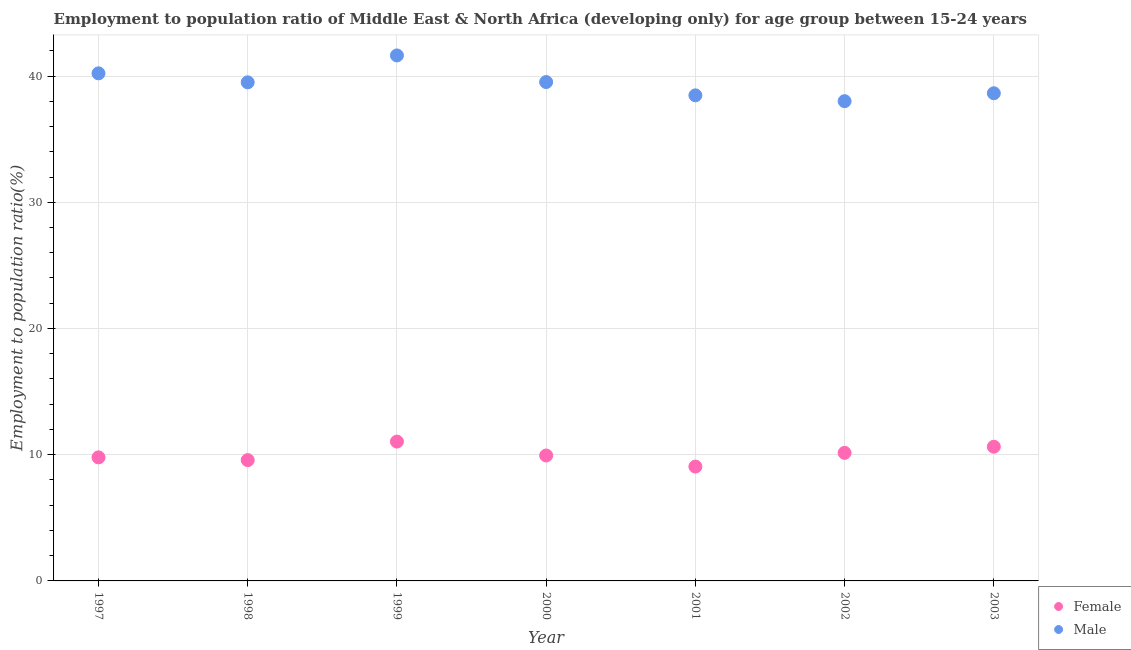Is the number of dotlines equal to the number of legend labels?
Your response must be concise. Yes. What is the employment to population ratio(female) in 2000?
Your answer should be very brief. 9.94. Across all years, what is the maximum employment to population ratio(male)?
Your answer should be very brief. 41.63. Across all years, what is the minimum employment to population ratio(female)?
Your response must be concise. 9.06. What is the total employment to population ratio(female) in the graph?
Offer a very short reply. 70.17. What is the difference between the employment to population ratio(female) in 2001 and that in 2002?
Your answer should be compact. -1.09. What is the difference between the employment to population ratio(male) in 1997 and the employment to population ratio(female) in 1998?
Your answer should be compact. 30.64. What is the average employment to population ratio(female) per year?
Your response must be concise. 10.02. In the year 1999, what is the difference between the employment to population ratio(female) and employment to population ratio(male)?
Offer a terse response. -30.59. In how many years, is the employment to population ratio(female) greater than 6 %?
Make the answer very short. 7. What is the ratio of the employment to population ratio(female) in 1997 to that in 1998?
Provide a succinct answer. 1.02. What is the difference between the highest and the second highest employment to population ratio(female)?
Ensure brevity in your answer.  0.41. What is the difference between the highest and the lowest employment to population ratio(female)?
Make the answer very short. 1.98. Is the employment to population ratio(female) strictly less than the employment to population ratio(male) over the years?
Your answer should be compact. Yes. Are the values on the major ticks of Y-axis written in scientific E-notation?
Give a very brief answer. No. Does the graph contain any zero values?
Ensure brevity in your answer.  No. Does the graph contain grids?
Make the answer very short. Yes. How are the legend labels stacked?
Keep it short and to the point. Vertical. What is the title of the graph?
Offer a very short reply. Employment to population ratio of Middle East & North Africa (developing only) for age group between 15-24 years. What is the label or title of the X-axis?
Provide a succinct answer. Year. What is the label or title of the Y-axis?
Your answer should be compact. Employment to population ratio(%). What is the Employment to population ratio(%) in Female in 1997?
Make the answer very short. 9.79. What is the Employment to population ratio(%) of Male in 1997?
Offer a very short reply. 40.21. What is the Employment to population ratio(%) of Female in 1998?
Your answer should be compact. 9.57. What is the Employment to population ratio(%) of Male in 1998?
Your response must be concise. 39.5. What is the Employment to population ratio(%) in Female in 1999?
Ensure brevity in your answer.  11.04. What is the Employment to population ratio(%) in Male in 1999?
Provide a succinct answer. 41.63. What is the Employment to population ratio(%) in Female in 2000?
Offer a very short reply. 9.94. What is the Employment to population ratio(%) of Male in 2000?
Provide a short and direct response. 39.52. What is the Employment to population ratio(%) in Female in 2001?
Your answer should be compact. 9.06. What is the Employment to population ratio(%) of Male in 2001?
Provide a succinct answer. 38.47. What is the Employment to population ratio(%) in Female in 2002?
Offer a terse response. 10.15. What is the Employment to population ratio(%) of Male in 2002?
Your answer should be very brief. 38.01. What is the Employment to population ratio(%) in Female in 2003?
Your answer should be compact. 10.63. What is the Employment to population ratio(%) of Male in 2003?
Keep it short and to the point. 38.63. Across all years, what is the maximum Employment to population ratio(%) in Female?
Keep it short and to the point. 11.04. Across all years, what is the maximum Employment to population ratio(%) of Male?
Provide a succinct answer. 41.63. Across all years, what is the minimum Employment to population ratio(%) in Female?
Give a very brief answer. 9.06. Across all years, what is the minimum Employment to population ratio(%) in Male?
Provide a succinct answer. 38.01. What is the total Employment to population ratio(%) in Female in the graph?
Provide a short and direct response. 70.17. What is the total Employment to population ratio(%) of Male in the graph?
Your answer should be very brief. 275.98. What is the difference between the Employment to population ratio(%) of Female in 1997 and that in 1998?
Give a very brief answer. 0.22. What is the difference between the Employment to population ratio(%) of Male in 1997 and that in 1998?
Make the answer very short. 0.71. What is the difference between the Employment to population ratio(%) of Female in 1997 and that in 1999?
Provide a short and direct response. -1.25. What is the difference between the Employment to population ratio(%) in Male in 1997 and that in 1999?
Make the answer very short. -1.42. What is the difference between the Employment to population ratio(%) in Female in 1997 and that in 2000?
Offer a terse response. -0.15. What is the difference between the Employment to population ratio(%) of Male in 1997 and that in 2000?
Offer a terse response. 0.69. What is the difference between the Employment to population ratio(%) in Female in 1997 and that in 2001?
Ensure brevity in your answer.  0.73. What is the difference between the Employment to population ratio(%) of Male in 1997 and that in 2001?
Your response must be concise. 1.74. What is the difference between the Employment to population ratio(%) in Female in 1997 and that in 2002?
Provide a succinct answer. -0.36. What is the difference between the Employment to population ratio(%) in Male in 1997 and that in 2002?
Ensure brevity in your answer.  2.21. What is the difference between the Employment to population ratio(%) of Female in 1997 and that in 2003?
Your response must be concise. -0.84. What is the difference between the Employment to population ratio(%) in Male in 1997 and that in 2003?
Your answer should be very brief. 1.58. What is the difference between the Employment to population ratio(%) of Female in 1998 and that in 1999?
Offer a terse response. -1.47. What is the difference between the Employment to population ratio(%) in Male in 1998 and that in 1999?
Give a very brief answer. -2.13. What is the difference between the Employment to population ratio(%) of Female in 1998 and that in 2000?
Offer a very short reply. -0.37. What is the difference between the Employment to population ratio(%) in Male in 1998 and that in 2000?
Offer a terse response. -0.02. What is the difference between the Employment to population ratio(%) of Female in 1998 and that in 2001?
Your answer should be very brief. 0.51. What is the difference between the Employment to population ratio(%) in Male in 1998 and that in 2001?
Your response must be concise. 1.03. What is the difference between the Employment to population ratio(%) of Female in 1998 and that in 2002?
Keep it short and to the point. -0.57. What is the difference between the Employment to population ratio(%) in Male in 1998 and that in 2002?
Your answer should be compact. 1.49. What is the difference between the Employment to population ratio(%) of Female in 1998 and that in 2003?
Make the answer very short. -1.06. What is the difference between the Employment to population ratio(%) of Male in 1998 and that in 2003?
Give a very brief answer. 0.87. What is the difference between the Employment to population ratio(%) of Female in 1999 and that in 2000?
Your response must be concise. 1.1. What is the difference between the Employment to population ratio(%) of Male in 1999 and that in 2000?
Your answer should be very brief. 2.11. What is the difference between the Employment to population ratio(%) in Female in 1999 and that in 2001?
Your answer should be very brief. 1.98. What is the difference between the Employment to population ratio(%) of Male in 1999 and that in 2001?
Your answer should be compact. 3.16. What is the difference between the Employment to population ratio(%) in Female in 1999 and that in 2002?
Keep it short and to the point. 0.89. What is the difference between the Employment to population ratio(%) of Male in 1999 and that in 2002?
Your answer should be compact. 3.62. What is the difference between the Employment to population ratio(%) of Female in 1999 and that in 2003?
Provide a succinct answer. 0.41. What is the difference between the Employment to population ratio(%) in Male in 1999 and that in 2003?
Ensure brevity in your answer.  3. What is the difference between the Employment to population ratio(%) of Female in 2000 and that in 2001?
Give a very brief answer. 0.88. What is the difference between the Employment to population ratio(%) of Male in 2000 and that in 2001?
Provide a short and direct response. 1.05. What is the difference between the Employment to population ratio(%) of Female in 2000 and that in 2002?
Provide a succinct answer. -0.21. What is the difference between the Employment to population ratio(%) in Male in 2000 and that in 2002?
Provide a short and direct response. 1.52. What is the difference between the Employment to population ratio(%) of Female in 2000 and that in 2003?
Keep it short and to the point. -0.69. What is the difference between the Employment to population ratio(%) of Male in 2000 and that in 2003?
Offer a very short reply. 0.89. What is the difference between the Employment to population ratio(%) of Female in 2001 and that in 2002?
Provide a succinct answer. -1.09. What is the difference between the Employment to population ratio(%) in Male in 2001 and that in 2002?
Provide a short and direct response. 0.46. What is the difference between the Employment to population ratio(%) of Female in 2001 and that in 2003?
Provide a short and direct response. -1.57. What is the difference between the Employment to population ratio(%) of Male in 2001 and that in 2003?
Keep it short and to the point. -0.17. What is the difference between the Employment to population ratio(%) of Female in 2002 and that in 2003?
Your answer should be compact. -0.49. What is the difference between the Employment to population ratio(%) in Male in 2002 and that in 2003?
Provide a succinct answer. -0.63. What is the difference between the Employment to population ratio(%) of Female in 1997 and the Employment to population ratio(%) of Male in 1998?
Your response must be concise. -29.71. What is the difference between the Employment to population ratio(%) in Female in 1997 and the Employment to population ratio(%) in Male in 1999?
Your answer should be very brief. -31.84. What is the difference between the Employment to population ratio(%) in Female in 1997 and the Employment to population ratio(%) in Male in 2000?
Make the answer very short. -29.74. What is the difference between the Employment to population ratio(%) in Female in 1997 and the Employment to population ratio(%) in Male in 2001?
Your answer should be compact. -28.68. What is the difference between the Employment to population ratio(%) of Female in 1997 and the Employment to population ratio(%) of Male in 2002?
Ensure brevity in your answer.  -28.22. What is the difference between the Employment to population ratio(%) of Female in 1997 and the Employment to population ratio(%) of Male in 2003?
Offer a very short reply. -28.85. What is the difference between the Employment to population ratio(%) of Female in 1998 and the Employment to population ratio(%) of Male in 1999?
Keep it short and to the point. -32.06. What is the difference between the Employment to population ratio(%) in Female in 1998 and the Employment to population ratio(%) in Male in 2000?
Your answer should be very brief. -29.95. What is the difference between the Employment to population ratio(%) in Female in 1998 and the Employment to population ratio(%) in Male in 2001?
Give a very brief answer. -28.9. What is the difference between the Employment to population ratio(%) of Female in 1998 and the Employment to population ratio(%) of Male in 2002?
Your answer should be compact. -28.44. What is the difference between the Employment to population ratio(%) in Female in 1998 and the Employment to population ratio(%) in Male in 2003?
Offer a terse response. -29.06. What is the difference between the Employment to population ratio(%) in Female in 1999 and the Employment to population ratio(%) in Male in 2000?
Your answer should be very brief. -28.48. What is the difference between the Employment to population ratio(%) in Female in 1999 and the Employment to population ratio(%) in Male in 2001?
Your response must be concise. -27.43. What is the difference between the Employment to population ratio(%) of Female in 1999 and the Employment to population ratio(%) of Male in 2002?
Your answer should be very brief. -26.97. What is the difference between the Employment to population ratio(%) in Female in 1999 and the Employment to population ratio(%) in Male in 2003?
Make the answer very short. -27.6. What is the difference between the Employment to population ratio(%) in Female in 2000 and the Employment to population ratio(%) in Male in 2001?
Ensure brevity in your answer.  -28.53. What is the difference between the Employment to population ratio(%) of Female in 2000 and the Employment to population ratio(%) of Male in 2002?
Your response must be concise. -28.07. What is the difference between the Employment to population ratio(%) of Female in 2000 and the Employment to population ratio(%) of Male in 2003?
Your response must be concise. -28.7. What is the difference between the Employment to population ratio(%) of Female in 2001 and the Employment to population ratio(%) of Male in 2002?
Offer a very short reply. -28.95. What is the difference between the Employment to population ratio(%) in Female in 2001 and the Employment to population ratio(%) in Male in 2003?
Provide a short and direct response. -29.58. What is the difference between the Employment to population ratio(%) of Female in 2002 and the Employment to population ratio(%) of Male in 2003?
Give a very brief answer. -28.49. What is the average Employment to population ratio(%) in Female per year?
Ensure brevity in your answer.  10.02. What is the average Employment to population ratio(%) of Male per year?
Ensure brevity in your answer.  39.43. In the year 1997, what is the difference between the Employment to population ratio(%) of Female and Employment to population ratio(%) of Male?
Your response must be concise. -30.43. In the year 1998, what is the difference between the Employment to population ratio(%) of Female and Employment to population ratio(%) of Male?
Your answer should be compact. -29.93. In the year 1999, what is the difference between the Employment to population ratio(%) in Female and Employment to population ratio(%) in Male?
Give a very brief answer. -30.59. In the year 2000, what is the difference between the Employment to population ratio(%) in Female and Employment to population ratio(%) in Male?
Provide a short and direct response. -29.59. In the year 2001, what is the difference between the Employment to population ratio(%) of Female and Employment to population ratio(%) of Male?
Ensure brevity in your answer.  -29.41. In the year 2002, what is the difference between the Employment to population ratio(%) of Female and Employment to population ratio(%) of Male?
Ensure brevity in your answer.  -27.86. In the year 2003, what is the difference between the Employment to population ratio(%) in Female and Employment to population ratio(%) in Male?
Provide a succinct answer. -28. What is the ratio of the Employment to population ratio(%) in Female in 1997 to that in 1998?
Offer a very short reply. 1.02. What is the ratio of the Employment to population ratio(%) of Male in 1997 to that in 1998?
Your answer should be very brief. 1.02. What is the ratio of the Employment to population ratio(%) of Female in 1997 to that in 1999?
Offer a very short reply. 0.89. What is the ratio of the Employment to population ratio(%) in Male in 1997 to that in 1999?
Keep it short and to the point. 0.97. What is the ratio of the Employment to population ratio(%) of Female in 1997 to that in 2000?
Your answer should be very brief. 0.98. What is the ratio of the Employment to population ratio(%) in Male in 1997 to that in 2000?
Your answer should be compact. 1.02. What is the ratio of the Employment to population ratio(%) in Female in 1997 to that in 2001?
Offer a terse response. 1.08. What is the ratio of the Employment to population ratio(%) in Male in 1997 to that in 2001?
Ensure brevity in your answer.  1.05. What is the ratio of the Employment to population ratio(%) in Female in 1997 to that in 2002?
Your answer should be compact. 0.96. What is the ratio of the Employment to population ratio(%) of Male in 1997 to that in 2002?
Offer a very short reply. 1.06. What is the ratio of the Employment to population ratio(%) of Female in 1997 to that in 2003?
Keep it short and to the point. 0.92. What is the ratio of the Employment to population ratio(%) in Male in 1997 to that in 2003?
Offer a terse response. 1.04. What is the ratio of the Employment to population ratio(%) in Female in 1998 to that in 1999?
Give a very brief answer. 0.87. What is the ratio of the Employment to population ratio(%) of Male in 1998 to that in 1999?
Offer a very short reply. 0.95. What is the ratio of the Employment to population ratio(%) of Female in 1998 to that in 2000?
Provide a succinct answer. 0.96. What is the ratio of the Employment to population ratio(%) in Female in 1998 to that in 2001?
Keep it short and to the point. 1.06. What is the ratio of the Employment to population ratio(%) of Male in 1998 to that in 2001?
Make the answer very short. 1.03. What is the ratio of the Employment to population ratio(%) of Female in 1998 to that in 2002?
Offer a terse response. 0.94. What is the ratio of the Employment to population ratio(%) in Male in 1998 to that in 2002?
Ensure brevity in your answer.  1.04. What is the ratio of the Employment to population ratio(%) of Female in 1998 to that in 2003?
Provide a succinct answer. 0.9. What is the ratio of the Employment to population ratio(%) in Male in 1998 to that in 2003?
Your answer should be very brief. 1.02. What is the ratio of the Employment to population ratio(%) in Female in 1999 to that in 2000?
Offer a very short reply. 1.11. What is the ratio of the Employment to population ratio(%) of Male in 1999 to that in 2000?
Ensure brevity in your answer.  1.05. What is the ratio of the Employment to population ratio(%) in Female in 1999 to that in 2001?
Your answer should be compact. 1.22. What is the ratio of the Employment to population ratio(%) in Male in 1999 to that in 2001?
Offer a very short reply. 1.08. What is the ratio of the Employment to population ratio(%) of Female in 1999 to that in 2002?
Your response must be concise. 1.09. What is the ratio of the Employment to population ratio(%) of Male in 1999 to that in 2002?
Your response must be concise. 1.1. What is the ratio of the Employment to population ratio(%) in Female in 1999 to that in 2003?
Offer a very short reply. 1.04. What is the ratio of the Employment to population ratio(%) in Male in 1999 to that in 2003?
Your answer should be compact. 1.08. What is the ratio of the Employment to population ratio(%) of Female in 2000 to that in 2001?
Ensure brevity in your answer.  1.1. What is the ratio of the Employment to population ratio(%) in Male in 2000 to that in 2001?
Ensure brevity in your answer.  1.03. What is the ratio of the Employment to population ratio(%) in Female in 2000 to that in 2002?
Your answer should be compact. 0.98. What is the ratio of the Employment to population ratio(%) in Male in 2000 to that in 2002?
Provide a short and direct response. 1.04. What is the ratio of the Employment to population ratio(%) in Female in 2000 to that in 2003?
Give a very brief answer. 0.93. What is the ratio of the Employment to population ratio(%) in Male in 2000 to that in 2003?
Keep it short and to the point. 1.02. What is the ratio of the Employment to population ratio(%) in Female in 2001 to that in 2002?
Your response must be concise. 0.89. What is the ratio of the Employment to population ratio(%) of Male in 2001 to that in 2002?
Give a very brief answer. 1.01. What is the ratio of the Employment to population ratio(%) in Female in 2001 to that in 2003?
Make the answer very short. 0.85. What is the ratio of the Employment to population ratio(%) of Female in 2002 to that in 2003?
Keep it short and to the point. 0.95. What is the ratio of the Employment to population ratio(%) in Male in 2002 to that in 2003?
Your answer should be very brief. 0.98. What is the difference between the highest and the second highest Employment to population ratio(%) of Female?
Your answer should be compact. 0.41. What is the difference between the highest and the second highest Employment to population ratio(%) in Male?
Provide a short and direct response. 1.42. What is the difference between the highest and the lowest Employment to population ratio(%) of Female?
Keep it short and to the point. 1.98. What is the difference between the highest and the lowest Employment to population ratio(%) of Male?
Provide a succinct answer. 3.62. 